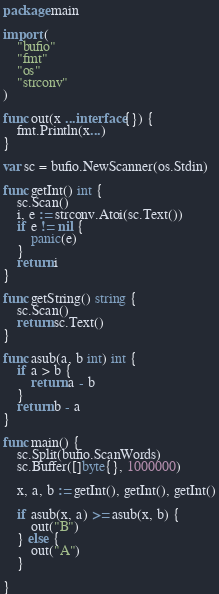Convert code to text. <code><loc_0><loc_0><loc_500><loc_500><_Go_>package main

import (
	"bufio"
	"fmt"
	"os"
	"strconv"
)

func out(x ...interface{}) {
	fmt.Println(x...)
}

var sc = bufio.NewScanner(os.Stdin)

func getInt() int {
	sc.Scan()
	i, e := strconv.Atoi(sc.Text())
	if e != nil {
		panic(e)
	}
	return i
}

func getString() string {
	sc.Scan()
	return sc.Text()
}

func asub(a, b int) int {
	if a > b {
		return a - b
	}
	return b - a
}

func main() {
	sc.Split(bufio.ScanWords)
	sc.Buffer([]byte{}, 1000000)

	x, a, b := getInt(), getInt(), getInt()

	if asub(x, a) >= asub(x, b) {
		out("B")
	} else {
		out("A")
	}

}
</code> 